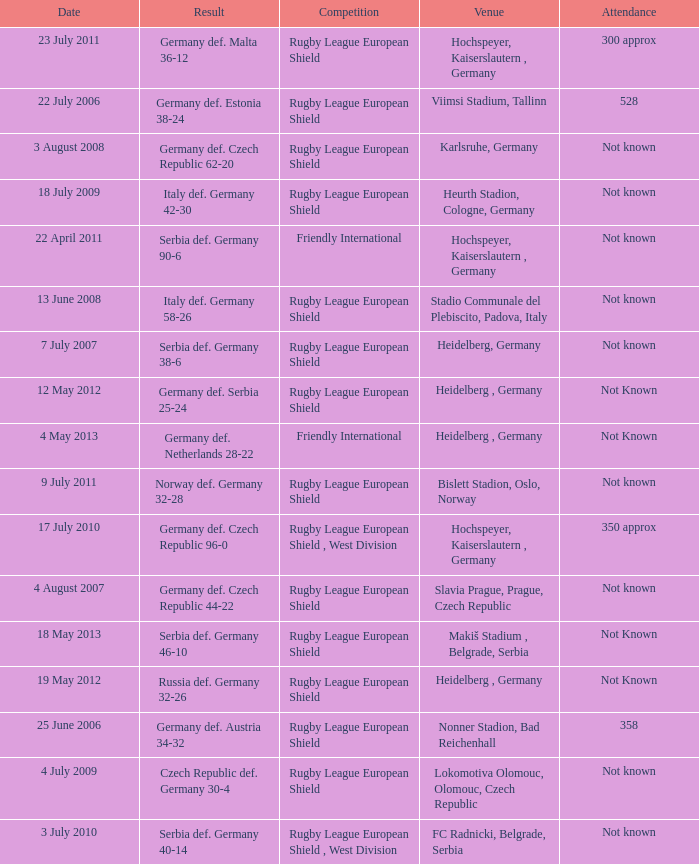For the game with 528 attendance, what was the result? Germany def. Estonia 38-24. 